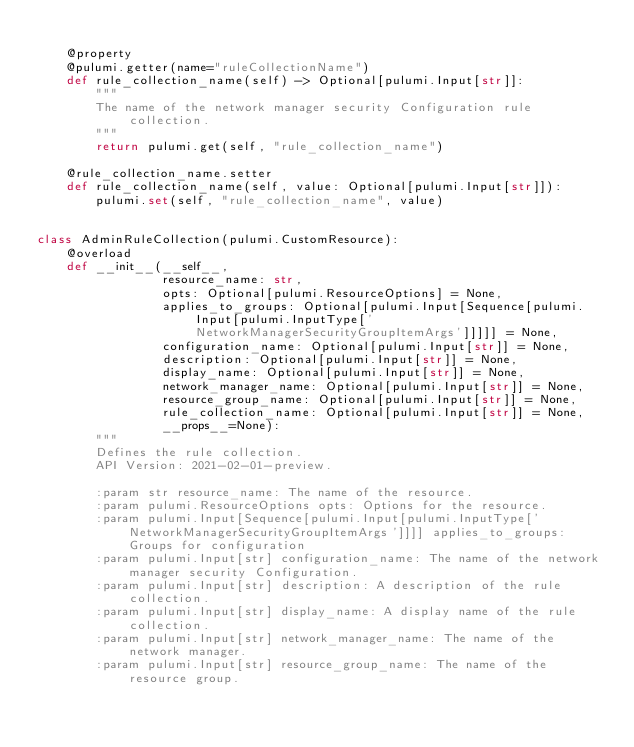Convert code to text. <code><loc_0><loc_0><loc_500><loc_500><_Python_>
    @property
    @pulumi.getter(name="ruleCollectionName")
    def rule_collection_name(self) -> Optional[pulumi.Input[str]]:
        """
        The name of the network manager security Configuration rule collection.
        """
        return pulumi.get(self, "rule_collection_name")

    @rule_collection_name.setter
    def rule_collection_name(self, value: Optional[pulumi.Input[str]]):
        pulumi.set(self, "rule_collection_name", value)


class AdminRuleCollection(pulumi.CustomResource):
    @overload
    def __init__(__self__,
                 resource_name: str,
                 opts: Optional[pulumi.ResourceOptions] = None,
                 applies_to_groups: Optional[pulumi.Input[Sequence[pulumi.Input[pulumi.InputType['NetworkManagerSecurityGroupItemArgs']]]]] = None,
                 configuration_name: Optional[pulumi.Input[str]] = None,
                 description: Optional[pulumi.Input[str]] = None,
                 display_name: Optional[pulumi.Input[str]] = None,
                 network_manager_name: Optional[pulumi.Input[str]] = None,
                 resource_group_name: Optional[pulumi.Input[str]] = None,
                 rule_collection_name: Optional[pulumi.Input[str]] = None,
                 __props__=None):
        """
        Defines the rule collection.
        API Version: 2021-02-01-preview.

        :param str resource_name: The name of the resource.
        :param pulumi.ResourceOptions opts: Options for the resource.
        :param pulumi.Input[Sequence[pulumi.Input[pulumi.InputType['NetworkManagerSecurityGroupItemArgs']]]] applies_to_groups: Groups for configuration
        :param pulumi.Input[str] configuration_name: The name of the network manager security Configuration.
        :param pulumi.Input[str] description: A description of the rule collection.
        :param pulumi.Input[str] display_name: A display name of the rule collection.
        :param pulumi.Input[str] network_manager_name: The name of the network manager.
        :param pulumi.Input[str] resource_group_name: The name of the resource group.</code> 